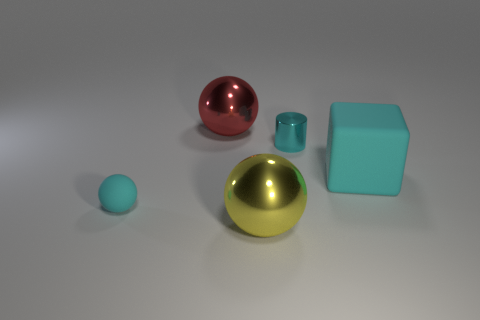Is there any other thing that is made of the same material as the red ball?
Keep it short and to the point. Yes. What material is the ball in front of the cyan object that is in front of the rubber thing that is right of the cyan metal cylinder?
Your response must be concise. Metal. The cyan object that is right of the tiny rubber ball and in front of the small cyan metal cylinder is made of what material?
Provide a succinct answer. Rubber. How many other tiny shiny things have the same shape as the small cyan shiny object?
Offer a terse response. 0. There is a cyan rubber object that is on the right side of the large metal ball that is behind the small cyan cylinder; what is its size?
Your answer should be compact. Large. Does the big sphere that is behind the big cube have the same color as the rubber object that is right of the big red sphere?
Provide a short and direct response. No. There is a small cyan object that is to the left of the shiny ball that is behind the large cube; what number of big cyan matte cubes are to the right of it?
Give a very brief answer. 1. What number of spheres are both behind the yellow sphere and on the right side of the tiny cyan ball?
Your response must be concise. 1. Are there more metal objects right of the big red metallic thing than large metal cylinders?
Provide a succinct answer. Yes. What number of cyan blocks are the same size as the yellow ball?
Your answer should be very brief. 1. 